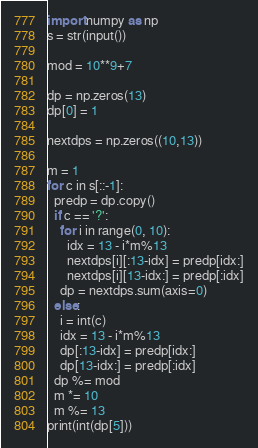<code> <loc_0><loc_0><loc_500><loc_500><_Python_>import numpy as np
s = str(input())

mod = 10**9+7

dp = np.zeros(13)
dp[0] = 1

nextdps = np.zeros((10,13))

m = 1
for c in s[::-1]:
  predp = dp.copy()
  if c == '?':
    for i in range(0, 10):
      idx = 13 - i*m%13
      nextdps[i][:13-idx] = predp[idx:]
      nextdps[i][13-idx:] = predp[:idx]
    dp = nextdps.sum(axis=0)
  else:
    i = int(c)
    idx = 13 - i*m%13
    dp[:13-idx] = predp[idx:]
    dp[13-idx:] = predp[:idx]
  dp %= mod
  m *= 10
  m %= 13
print(int(dp[5]))</code> 